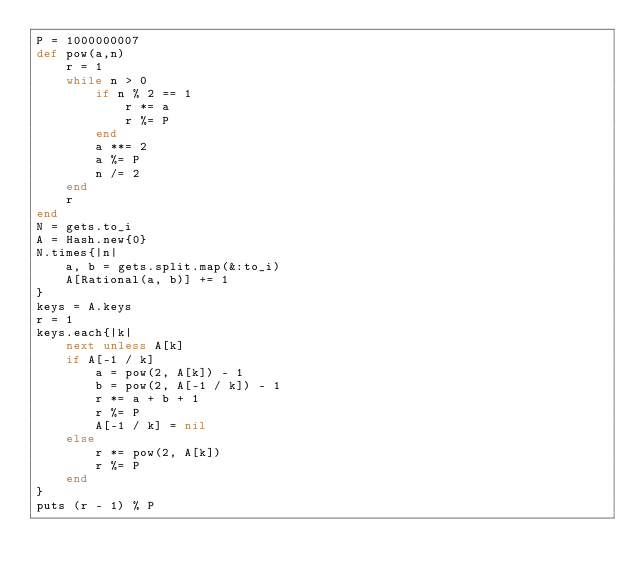<code> <loc_0><loc_0><loc_500><loc_500><_Ruby_>P = 1000000007
def pow(a,n)
	r = 1
	while n > 0
		if n % 2 == 1
			r *= a
			r %= P
		end
		a **= 2
		a %= P
		n /= 2
	end
	r
end
N = gets.to_i
A = Hash.new{0}
N.times{|n|
	a, b = gets.split.map(&:to_i)
	A[Rational(a, b)] += 1
}
keys = A.keys
r = 1
keys.each{|k|
	next unless A[k]
	if A[-1 / k]
		a = pow(2, A[k]) - 1
		b = pow(2, A[-1 / k]) - 1
		r *= a + b + 1
		r %= P
		A[-1 / k] = nil
	else
		r *= pow(2, A[k])
		r %= P
	end
}
puts (r - 1) % P
</code> 